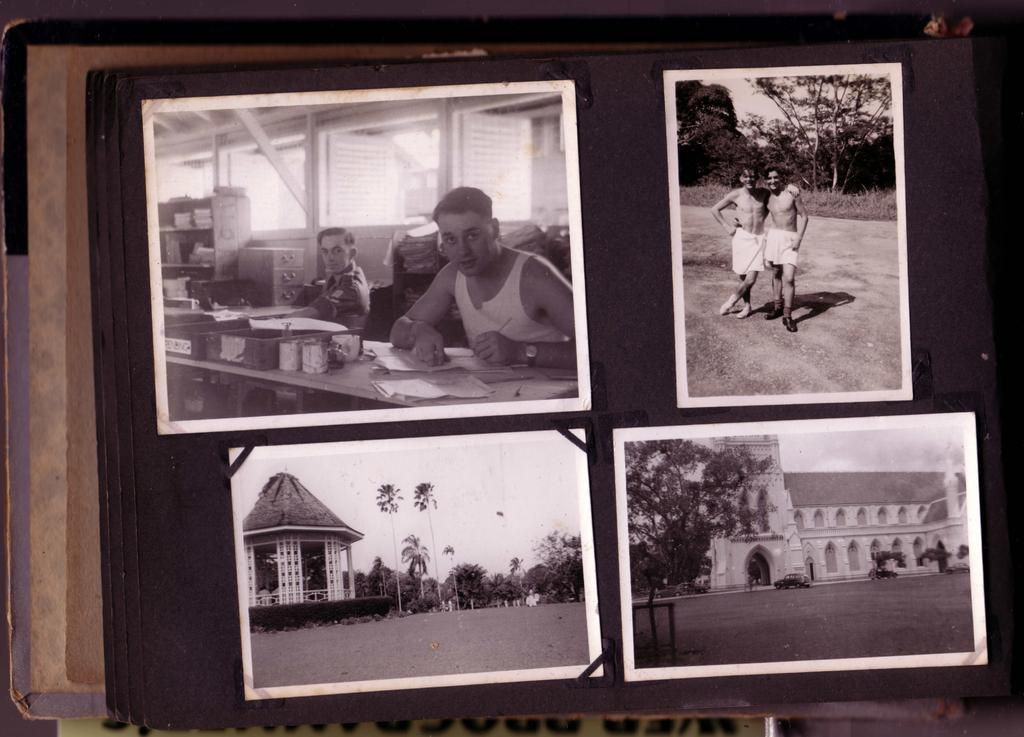In one or two sentences, can you explain what this image depicts? In this image we can see there are four black and white photos on a bulletin board, in the first image we can see there are two people sitting behind a table, in the second image there are two people posing for a picture, in the third and fourth pictures there are houses and trees. 